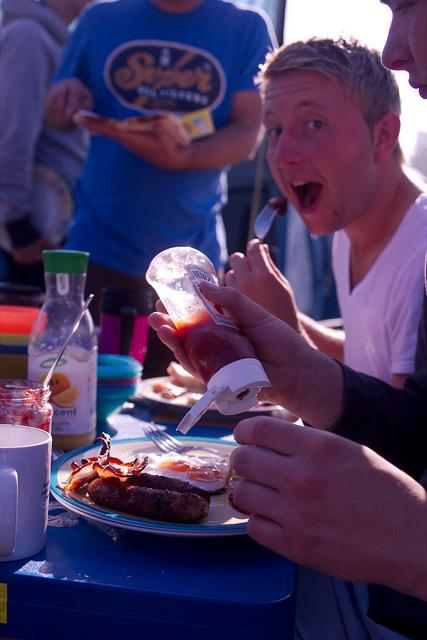Why are the men seated?

Choices:
A) to eat
B) play chess
C) draw
D) to work to eat 